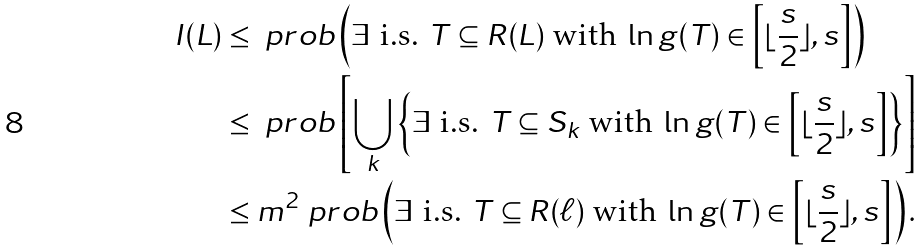<formula> <loc_0><loc_0><loc_500><loc_500>I ( L ) & \leq \ p r o b \left ( \exists \text { i.s. } T \subseteq R ( L ) \text { with } \ln g ( T ) \in \left [ \lfloor \frac { s } { 2 } \rfloor , s \right ] \right ) \\ & \leq \ p r o b \left [ \bigcup _ { k } \left \{ \exists \text { i.s. } T \subseteq S _ { k } \text { with } \ln g ( T ) \in \left [ \lfloor \frac { s } { 2 } \rfloor , s \right ] \right \} \right ] \\ & \leq m ^ { 2 } \ p r o b \left ( \exists \text { i.s. } T \subseteq R ( \ell ) \text { with } \ln g ( T ) \in \left [ \lfloor \frac { s } { 2 } \rfloor , s \right ] \right ) .</formula> 